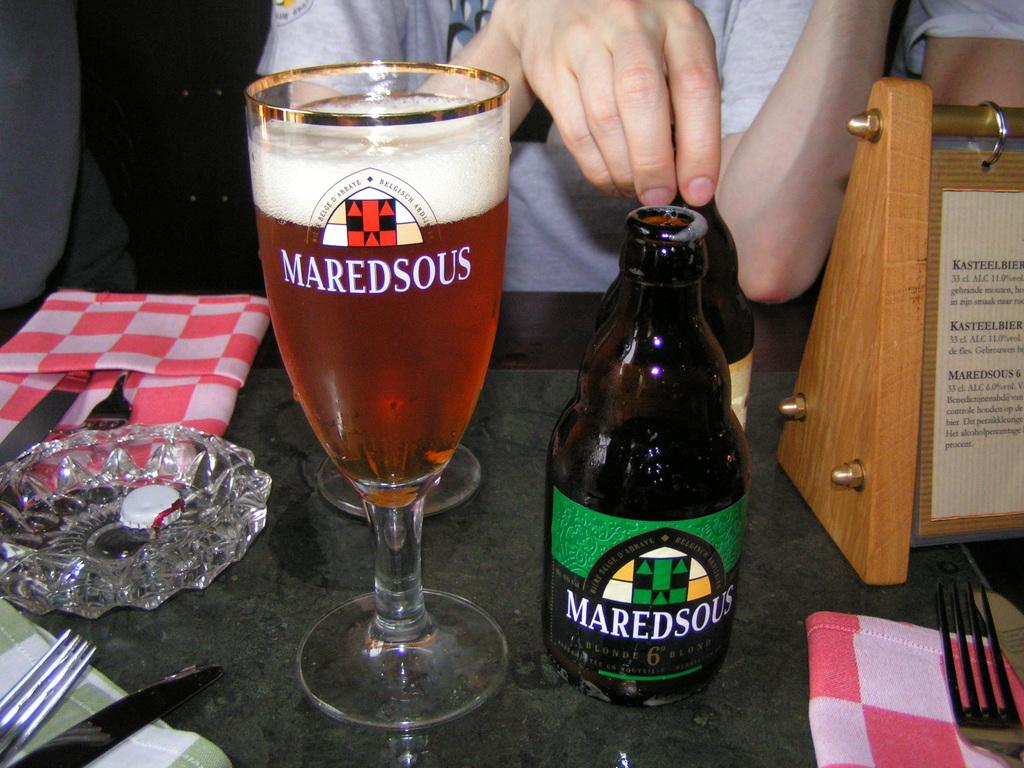<image>
Relay a brief, clear account of the picture shown. A glass of beer next to a bottle of Maredsous blonde. 